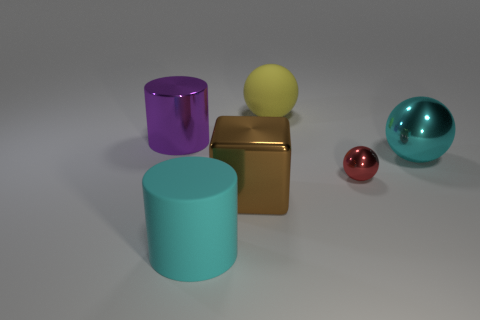Are there any red metallic objects in front of the large shiny thing that is in front of the big thing to the right of the yellow thing? no 